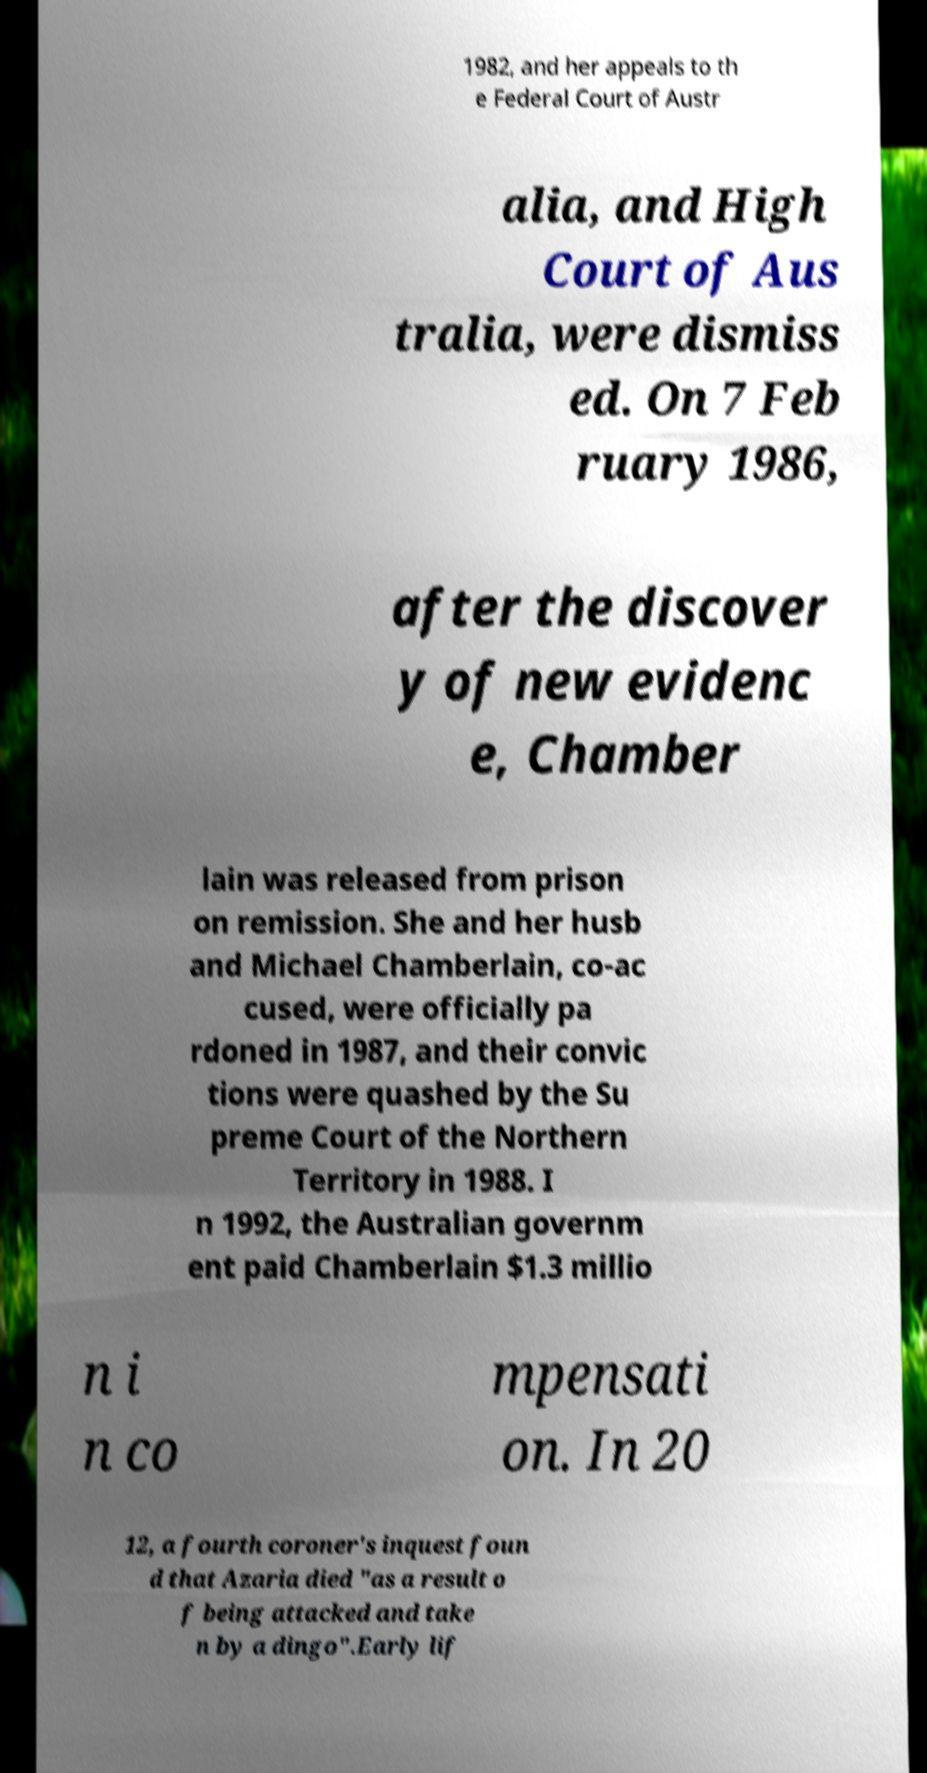Please read and relay the text visible in this image. What does it say? 1982, and her appeals to th e Federal Court of Austr alia, and High Court of Aus tralia, were dismiss ed. On 7 Feb ruary 1986, after the discover y of new evidenc e, Chamber lain was released from prison on remission. She and her husb and Michael Chamberlain, co-ac cused, were officially pa rdoned in 1987, and their convic tions were quashed by the Su preme Court of the Northern Territory in 1988. I n 1992, the Australian governm ent paid Chamberlain $1.3 millio n i n co mpensati on. In 20 12, a fourth coroner's inquest foun d that Azaria died "as a result o f being attacked and take n by a dingo".Early lif 